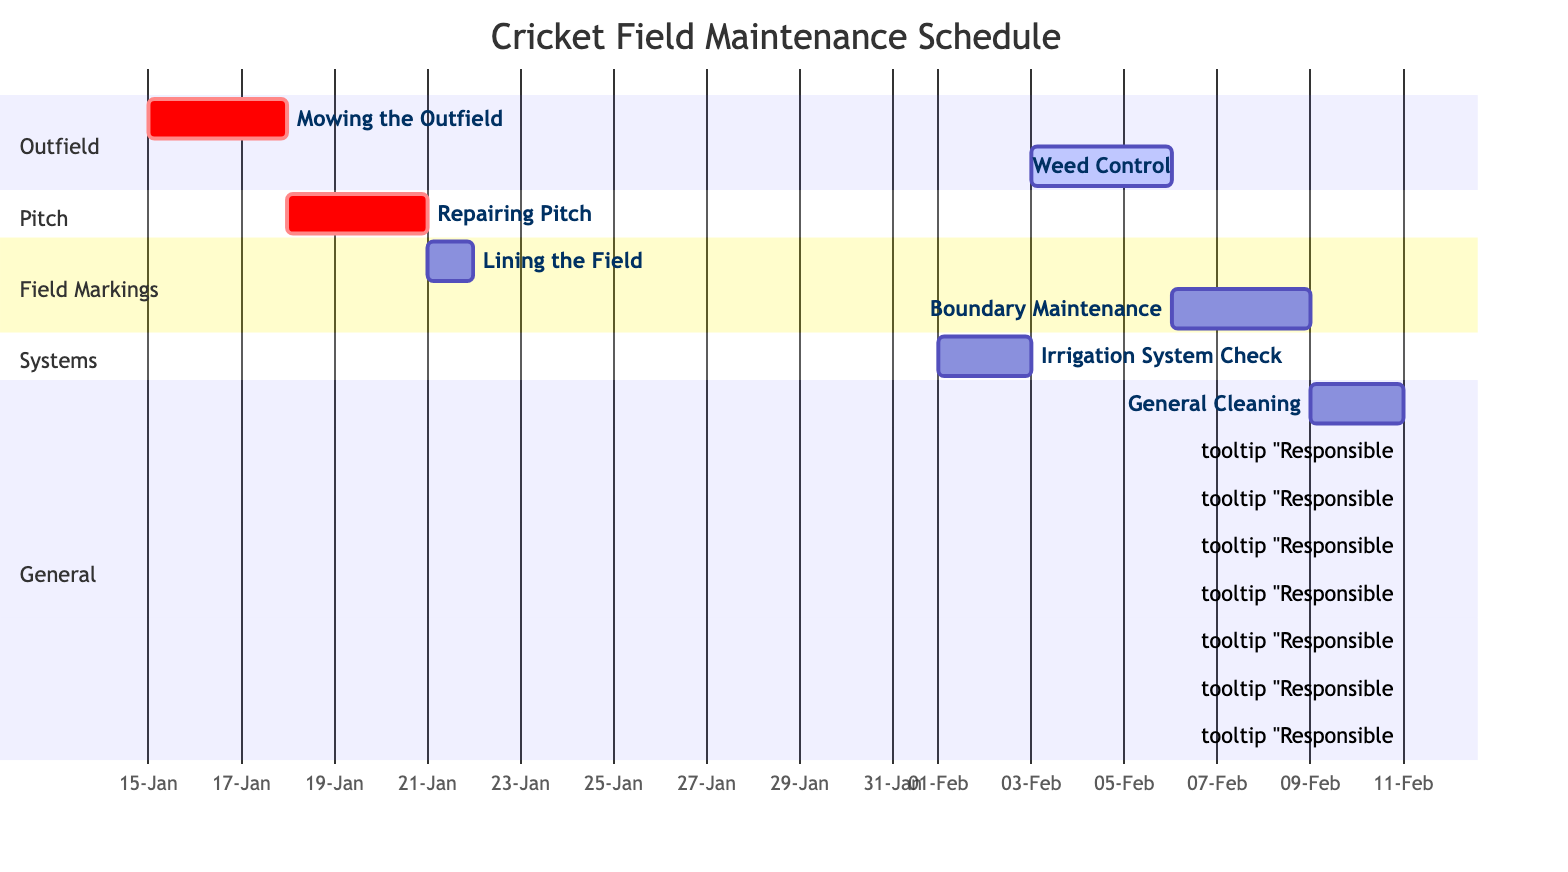What is the duration of the "Mowing the Outfield" task? The task "Mowing the Outfield" starts on January 15, 2024, and ends on January 17, 2024, which is a total of 3 days.
Answer: 3 days Who is responsible for "Weed Control"? The task "Weed Control" is assigned to Samantha White, as indicated in the diagram.
Answer: Samantha White On which date does "General Cleaning" start? The "General Cleaning" task starts on February 9, 2024, which is stated in the date section of the task.
Answer: February 9, 2024 How many tasks are scheduled in February? There are four tasks scheduled in February: "Irrigation System Check," "Weed Control," "Boundary Maintenance," and "General Cleaning." This is counted from the tasks listed in the relevant sections.
Answer: 4 tasks Which task follows "Repairing Pitch"? After "Repairing Pitch," the next task is "Lining the Field," which starts on January 21, 2024. This is determined by looking at the sequence of tasks based on the timeline.
Answer: Lining the Field What is the end date of the "Boundary Maintenance" task? The "Boundary Maintenance" task ends on February 8, 2024, as shown in the diagram. This can be found by checking the end date specified for this task.
Answer: February 8, 2024 Which task is due for checking the irrigation system? The task focused on checking the irrigation system is "Irrigation System Check," as clearly indicated among the tasks listed in the sections.
Answer: Irrigation System Check Who is responsible for "Lining the Field"? The "Lining the Field" task is assigned to Lisa Green, which is mentioned in the responsibility label of this task in the diagram.
Answer: Lisa Green 